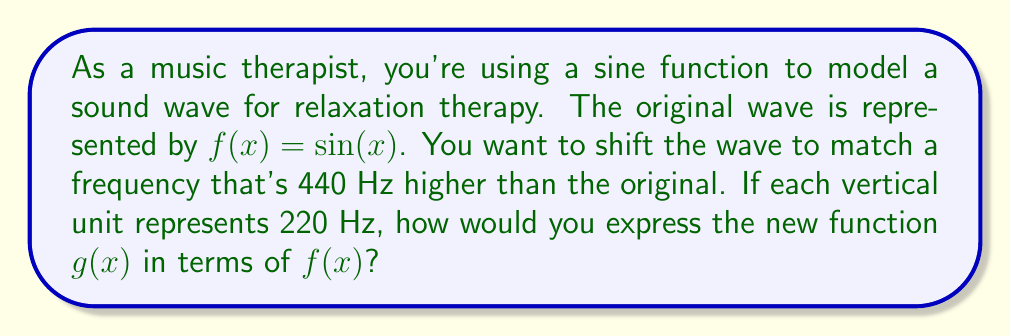Provide a solution to this math problem. Let's approach this step-by-step:

1) First, we need to understand what a vertical shift does to a function. A vertical shift moves the entire graph up or down.

2) The general form of a vertical shift is:
   $g(x) = f(x) + k$, where $k$ is the amount of the shift.

3) In this problem, we need to shift the frequency up by 440 Hz.

4) We're told that each vertical unit represents 220 Hz. So, to find how many units we need to shift, we divide:
   $\frac{440 \text{ Hz}}{220 \text{ Hz/unit}} = 2 \text{ units}$

5) Therefore, we need to shift the function up by 2 units.

6) Using the general form of a vertical shift, we can express $g(x)$ as:
   $g(x) = f(x) + 2$

7) Since $f(x) = \sin(x)$, we can write the final function as:
   $g(x) = \sin(x) + 2$

This new function $g(x)$ represents the sound wave with a frequency 440 Hz higher than the original wave.
Answer: $g(x) = f(x) + 2$ or $g(x) = \sin(x) + 2$ 